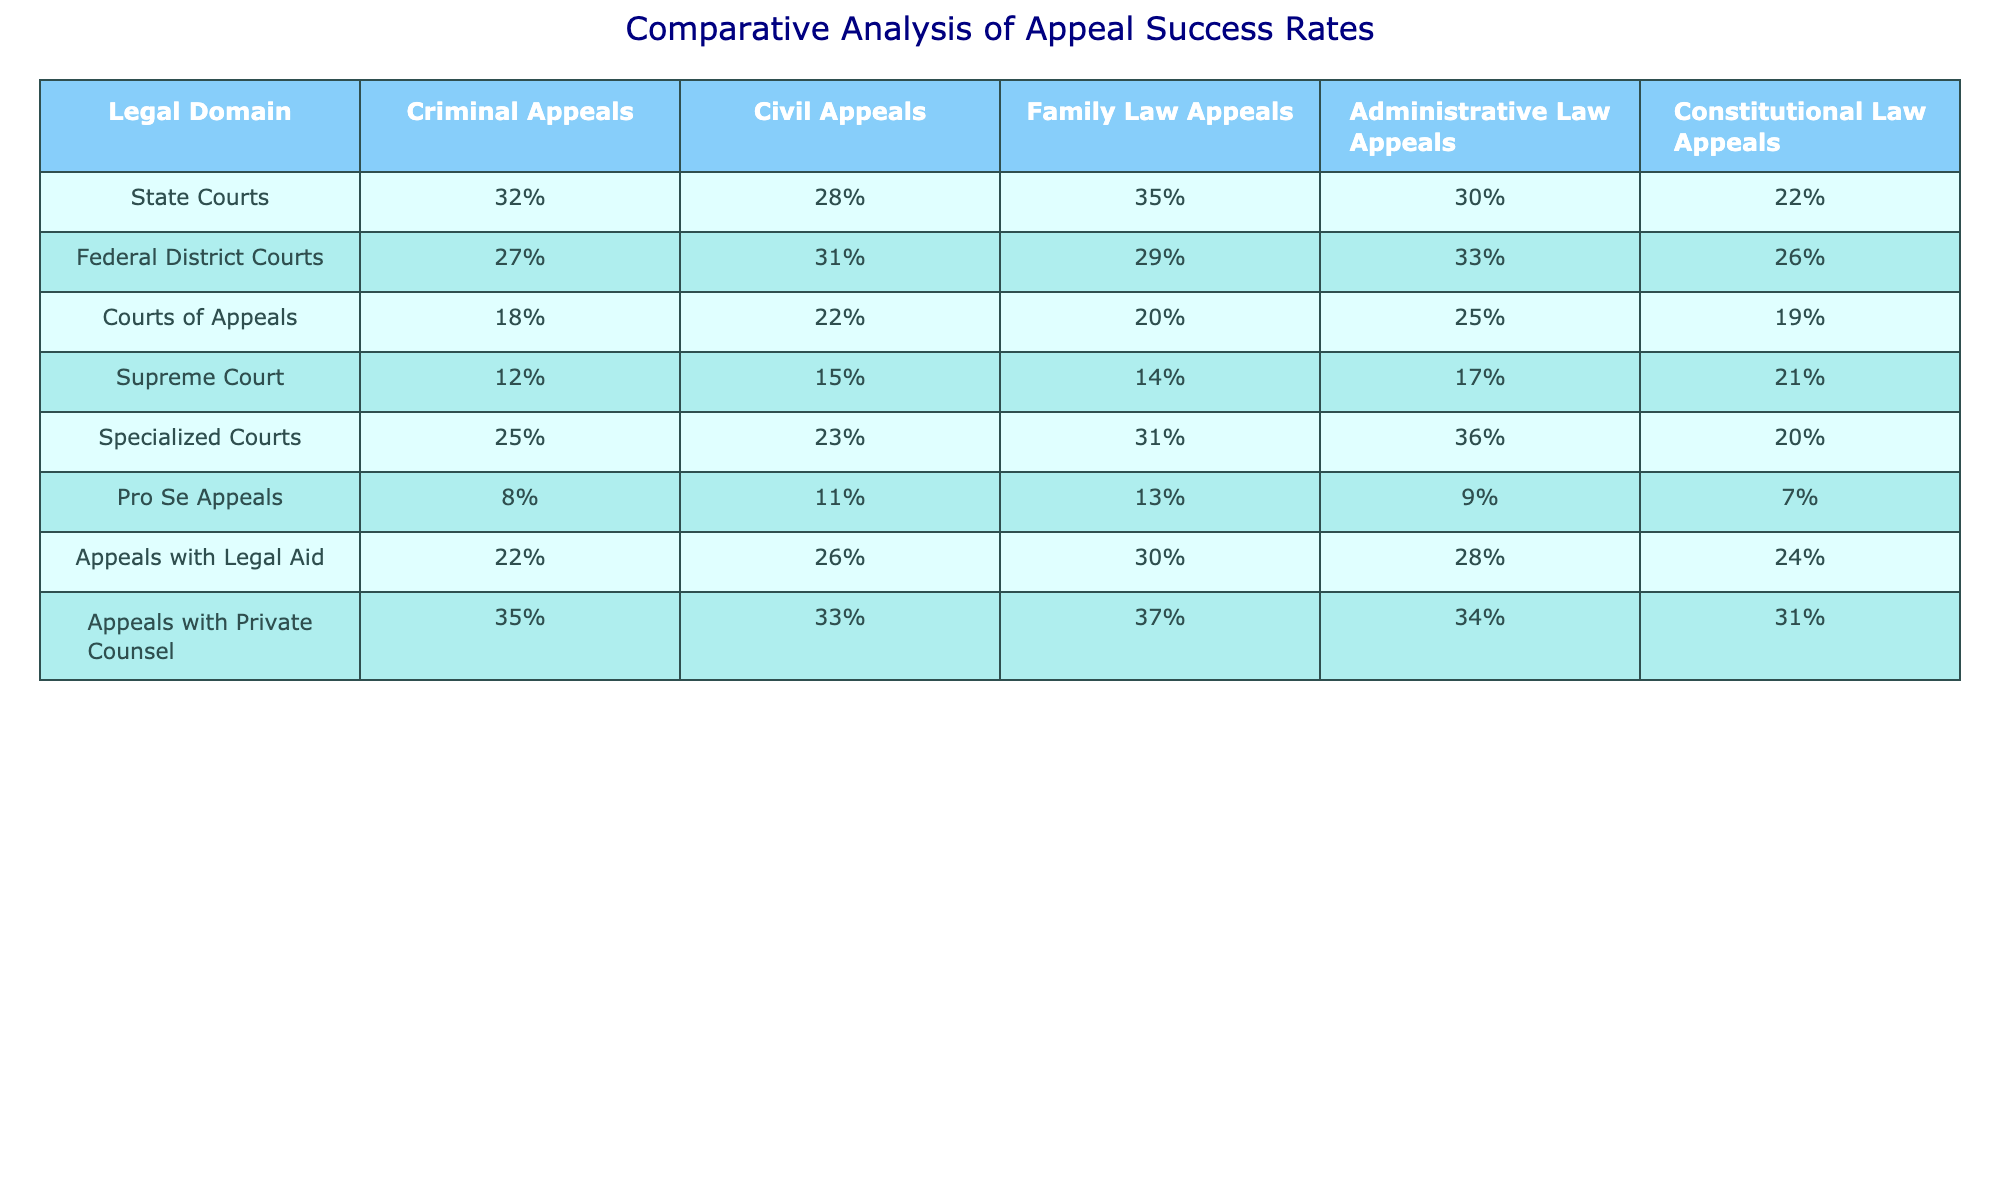What is the success rate for Criminal Appeals in State Courts? Referring to the table, the success rate for Criminal Appeals in State Courts is listed as 32%.
Answer: 32% Which legal domain has the highest appeal success rate with Private Counsel? Looking at the Private Counsel row, the highest success rate is for Family Law Appeals at 37%.
Answer: 37% What is the average success rate for Administrative Law Appeals across all court types? To calculate the average, sum the success rates: (30 + 33 + 25 + 17 + 36 + 9 + 28 + 34) = 312, then divide by 8 to get 39%.
Answer: 39% Is the success rate for Appeals with Legal Aid higher than for Pro Se Appeals in Family Law? Checking the Family Law Appeals column, Appeals with Legal Aid has a success rate of 30%, while Pro Se Appeals has 13%. Since 30 > 13, the statement is true.
Answer: Yes What is the difference in success rates for Constitutional Law Appeals between State Courts and Courts of Appeals? In State Courts, the success rate is 22%, while in Courts of Appeals, it is 19%. The difference is calculated as 22 - 19 = 3%.
Answer: 3% Which court type has the lowest success rate for Pro Se Appeals? Looking at the Pro Se Appeals row, the lowest success rate is 7%, which corresponds to Constitutional Law Appeals.
Answer: 7% What is the highest appeal success rate for Administrative Law Appeals across the different court types? By examining the Administrative Law Appeals column, the highest success rate is 36%, found in Specialized Courts.
Answer: 36% In which domain do Appeals with Legal Aid show the greatest disparity compared to Pro Se Appeals? Comparing the success rates: Family Law Appeals have 30% with Legal Aid and 13% for Pro Se Appeals, showing a disparity of 17%. This is greater than any other domain.
Answer: Family Law Appeals Can you determine which type of court generally has the lowest appeal success rates across all legal domains? Analyzing the rows, Courts of Appeals show the lowest success rates in most legal domains compared to others, with values primarily in the teens.
Answer: Courts of Appeals What is the percentage increase in success rate for Civil Appeals from Pro Se Appeals to Appeals with Private Counsel? For Civil Appeals, Pro Se Appeals have a success rate of 11% and Appeals with Private Counsel have 33%. The percentage increase is calculated as (33 - 11) / 11 * 100 = 200%.
Answer: 200% 